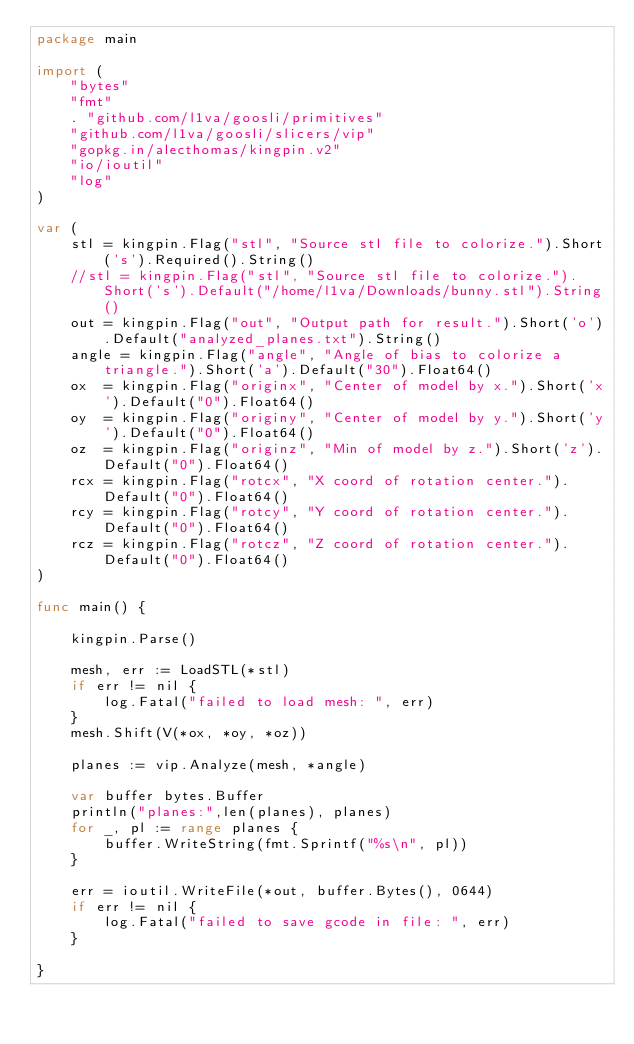Convert code to text. <code><loc_0><loc_0><loc_500><loc_500><_Go_>package main

import (
	"bytes"
	"fmt"
	. "github.com/l1va/goosli/primitives"
	"github.com/l1va/goosli/slicers/vip"
	"gopkg.in/alecthomas/kingpin.v2"
	"io/ioutil"
	"log"
)

var (
	stl = kingpin.Flag("stl", "Source stl file to colorize.").Short('s').Required().String()
	//stl = kingpin.Flag("stl", "Source stl file to colorize.").Short('s').Default("/home/l1va/Downloads/bunny.stl").String()
	out = kingpin.Flag("out", "Output path for result.").Short('o').Default("analyzed_planes.txt").String()
	angle = kingpin.Flag("angle", "Angle of bias to colorize a triangle.").Short('a').Default("30").Float64()
	ox  = kingpin.Flag("originx", "Center of model by x.").Short('x').Default("0").Float64()
	oy  = kingpin.Flag("originy", "Center of model by y.").Short('y').Default("0").Float64()
	oz  = kingpin.Flag("originz", "Min of model by z.").Short('z').Default("0").Float64()
	rcx = kingpin.Flag("rotcx", "X coord of rotation center.").Default("0").Float64()
	rcy = kingpin.Flag("rotcy", "Y coord of rotation center.").Default("0").Float64()
	rcz = kingpin.Flag("rotcz", "Z coord of rotation center.").Default("0").Float64()
)

func main() {

	kingpin.Parse()

	mesh, err := LoadSTL(*stl)
	if err != nil {
		log.Fatal("failed to load mesh: ", err)
	}
	mesh.Shift(V(*ox, *oy, *oz))

	planes := vip.Analyze(mesh, *angle)

	var buffer bytes.Buffer
	println("planes:",len(planes), planes)
	for _, pl := range planes {
		buffer.WriteString(fmt.Sprintf("%s\n", pl))
	}

	err = ioutil.WriteFile(*out, buffer.Bytes(), 0644)
	if err != nil {
		log.Fatal("failed to save gcode in file: ", err)
	}

}
</code> 